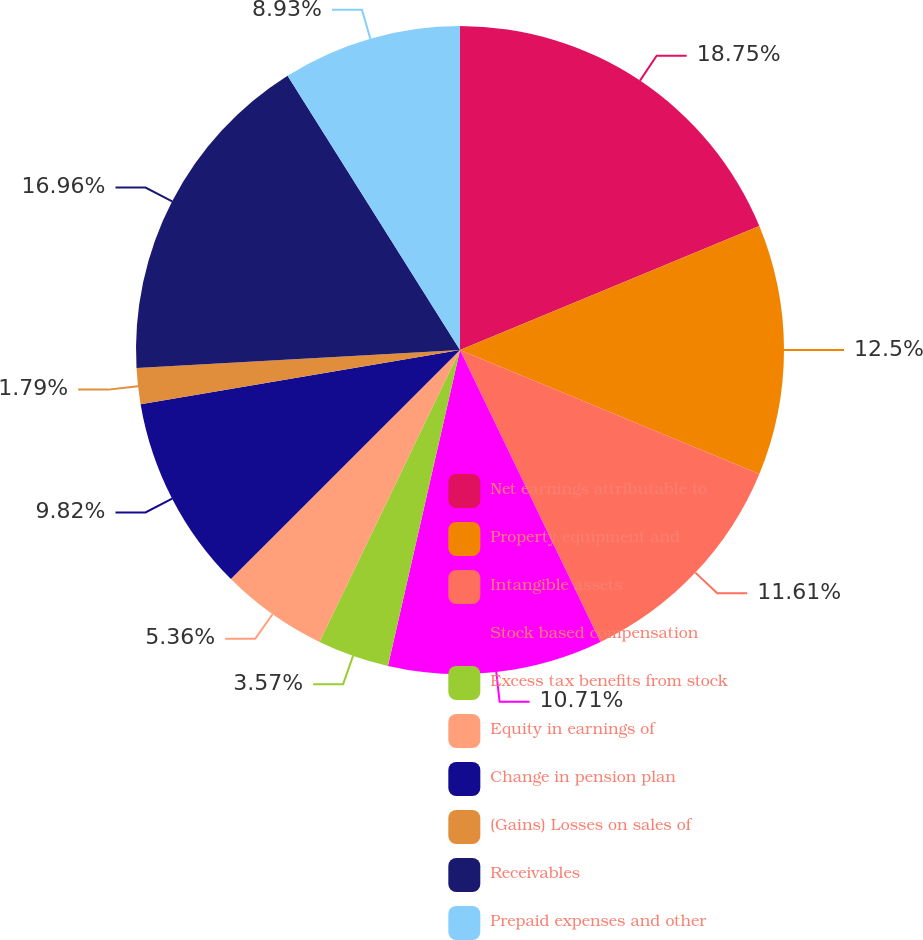<chart> <loc_0><loc_0><loc_500><loc_500><pie_chart><fcel>Net earnings attributable to<fcel>Property equipment and<fcel>Intangible assets<fcel>Stock based compensation<fcel>Excess tax benefits from stock<fcel>Equity in earnings of<fcel>Change in pension plan<fcel>(Gains) Losses on sales of<fcel>Receivables<fcel>Prepaid expenses and other<nl><fcel>18.75%<fcel>12.5%<fcel>11.61%<fcel>10.71%<fcel>3.57%<fcel>5.36%<fcel>9.82%<fcel>1.79%<fcel>16.96%<fcel>8.93%<nl></chart> 